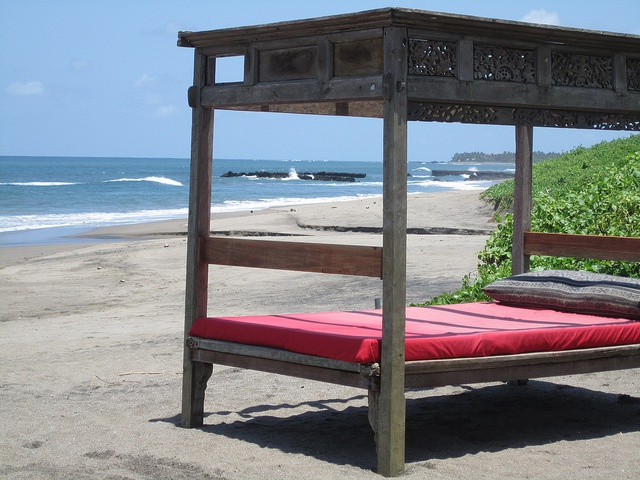Describe the objects in this image and their specific colors. I can see a bed in lightblue, black, gray, and maroon tones in this image. 